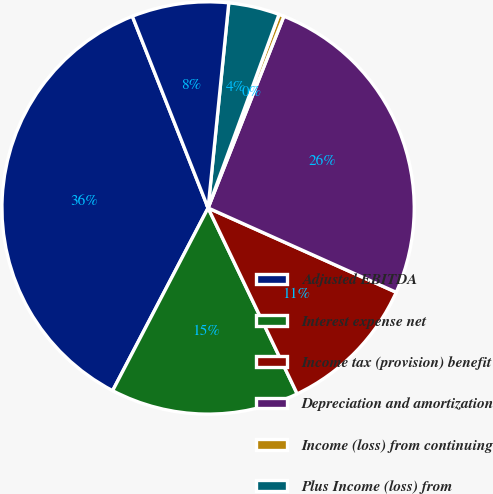<chart> <loc_0><loc_0><loc_500><loc_500><pie_chart><fcel>Adjusted EBITDA<fcel>Interest expense net<fcel>Income tax (provision) benefit<fcel>Depreciation and amortization<fcel>Income (loss) from continuing<fcel>Plus Income (loss) from<fcel>Net income (loss) attributable<nl><fcel>36.35%<fcel>14.78%<fcel>11.18%<fcel>25.72%<fcel>0.4%<fcel>3.99%<fcel>7.59%<nl></chart> 